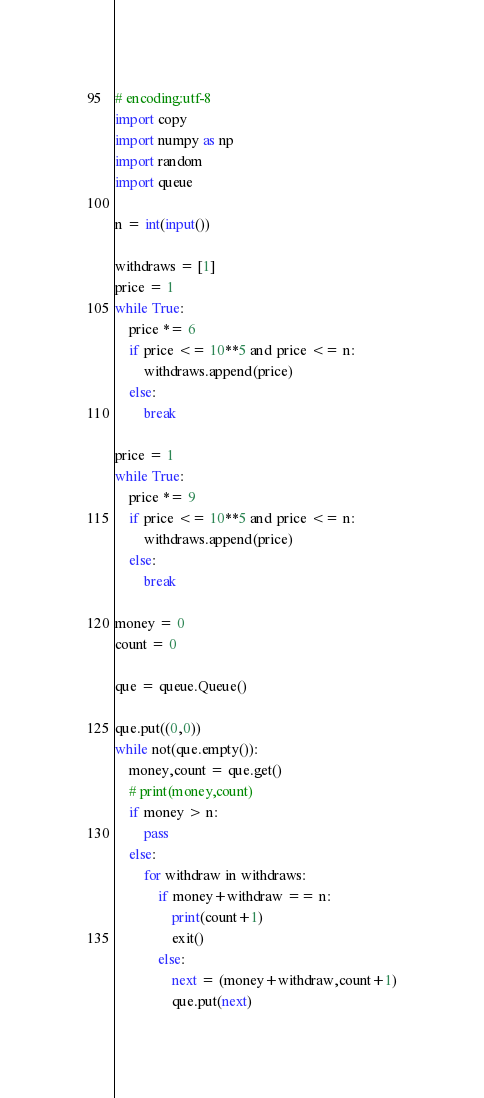Convert code to text. <code><loc_0><loc_0><loc_500><loc_500><_Python_># encoding:utf-8
import copy
import numpy as np
import random
import queue

n = int(input())

withdraws = [1]
price = 1
while True:
    price *= 6
    if price <= 10**5 and price <= n:
        withdraws.append(price)
    else:
        break

price = 1
while True:
    price *= 9
    if price <= 10**5 and price <= n:
        withdraws.append(price)
    else:
        break

money = 0
count = 0

que = queue.Queue()

que.put((0,0))
while not(que.empty()):
    money,count = que.get()
    # print(money,count)
    if money > n:
        pass
    else:
        for withdraw in withdraws:
            if money+withdraw == n:
                print(count+1)
                exit()
            else:
                next = (money+withdraw,count+1)
                que.put(next)
</code> 